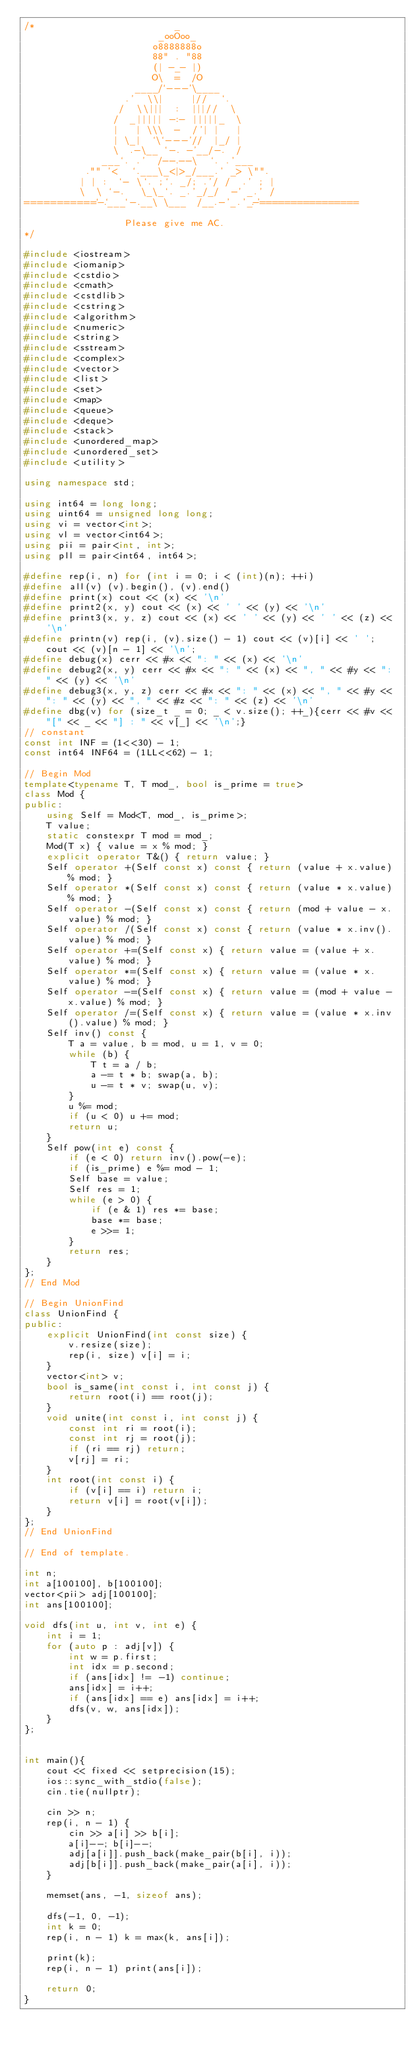Convert code to text. <code><loc_0><loc_0><loc_500><loc_500><_C++_>/*                         _
                        _ooOoo_
                       o8888888o
                       88" . "88
                       (| -_- |)
                       O\  =  /O
                    ____/`---'\____
                  .'  \\|     |//  `.
                 /  \\|||  :  |||//  \
                /  _||||| -:- |||||_  \
                |   | \\\  -  /'| |   |
                | \_|  `\`---'//  |_/ |
                \  .-\__ `-. -'__/-.  /
              ___`. .'  /--.--\  `. .'___
           ."" '<  `.___\_<|>_/___.' _> \"".
          | | :  `- \`. ;`. _/; .'/ /  .' ; |
          \  \ `-.   \_\_`. _.'_/_/  -' _.' /
===========`-.`___`-.__\ \___  /__.-'_.'_.-'================

                  Please give me AC.
*/

#include <iostream>
#include <iomanip>
#include <cstdio>
#include <cmath>
#include <cstdlib>
#include <cstring>
#include <algorithm>
#include <numeric>
#include <string>
#include <sstream>
#include <complex>
#include <vector>
#include <list>
#include <set>
#include <map>
#include <queue>
#include <deque>
#include <stack>
#include <unordered_map>
#include <unordered_set>
#include <utility>

using namespace std;

using int64 = long long;
using uint64 = unsigned long long;
using vi = vector<int>;
using vl = vector<int64>;
using pii = pair<int, int>;
using pll = pair<int64, int64>;

#define rep(i, n) for (int i = 0; i < (int)(n); ++i)
#define all(v) (v).begin(), (v).end()
#define print(x) cout << (x) << '\n'
#define print2(x, y) cout << (x) << ' ' << (y) << '\n'
#define print3(x, y, z) cout << (x) << ' ' << (y) << ' ' << (z) << '\n'
#define printn(v) rep(i, (v).size() - 1) cout << (v)[i] << ' '; cout << (v)[n - 1] << '\n';
#define debug(x) cerr << #x << ": " << (x) << '\n'
#define debug2(x, y) cerr << #x << ": " << (x) << ", " << #y << ": " << (y) << '\n'
#define debug3(x, y, z) cerr << #x << ": " << (x) << ", " << #y << ": " << (y) << ", " << #z << ": " << (z) << '\n'
#define dbg(v) for (size_t _ = 0; _ < v.size(); ++_){cerr << #v << "[" << _ << "] : " << v[_] << '\n';}
// constant
const int INF = (1<<30) - 1;
const int64 INF64 = (1LL<<62) - 1;

// Begin Mod
template<typename T, T mod_, bool is_prime = true>
class Mod {
public:
    using Self = Mod<T, mod_, is_prime>;
    T value;
    static constexpr T mod = mod_;
    Mod(T x) { value = x % mod; }
    explicit operator T&() { return value; }
    Self operator +(Self const x) const { return (value + x.value) % mod; }
    Self operator *(Self const x) const { return (value * x.value) % mod; }
    Self operator -(Self const x) const { return (mod + value - x.value) % mod; }
    Self operator /(Self const x) const { return (value * x.inv().value) % mod; }
    Self operator +=(Self const x) { return value = (value + x.value) % mod; }
    Self operator *=(Self const x) { return value = (value * x.value) % mod; }
    Self operator -=(Self const x) { return value = (mod + value - x.value) % mod; }
    Self operator /=(Self const x) { return value = (value * x.inv().value) % mod; }
    Self inv() const {
        T a = value, b = mod, u = 1, v = 0;
        while (b) {
            T t = a / b;
            a -= t * b; swap(a, b);
            u -= t * v; swap(u, v);
        }
        u %= mod;
        if (u < 0) u += mod;
        return u;
    }
    Self pow(int e) const {
        if (e < 0) return inv().pow(-e);
        if (is_prime) e %= mod - 1;
        Self base = value;
        Self res = 1;
        while (e > 0) {
            if (e & 1) res *= base;
            base *= base;
            e >>= 1;
        }
        return res;
    }
};
// End Mod

// Begin UnionFind
class UnionFind {
public:
    explicit UnionFind(int const size) {
        v.resize(size);
        rep(i, size) v[i] = i;
    }
    vector<int> v;
    bool is_same(int const i, int const j) {
        return root(i) == root(j);
    }
    void unite(int const i, int const j) {
        const int ri = root(i);
        const int rj = root(j);
        if (ri == rj) return;
        v[rj] = ri;
    }
    int root(int const i) {
        if (v[i] == i) return i;
        return v[i] = root(v[i]);
    }
};
// End UnionFind

// End of template.

int n;
int a[100100], b[100100];
vector<pii> adj[100100];
int ans[100100];

void dfs(int u, int v, int e) {
    int i = 1;
    for (auto p : adj[v]) {
        int w = p.first;
        int idx = p.second;
        if (ans[idx] != -1) continue;
        ans[idx] = i++;
        if (ans[idx] == e) ans[idx] = i++;
        dfs(v, w, ans[idx]);
    }
};


int main(){
    cout << fixed << setprecision(15);
    ios::sync_with_stdio(false);
    cin.tie(nullptr);

    cin >> n;
    rep(i, n - 1) {
        cin >> a[i] >> b[i];
        a[i]--; b[i]--;
        adj[a[i]].push_back(make_pair(b[i], i));
        adj[b[i]].push_back(make_pair(a[i], i));
    }

    memset(ans, -1, sizeof ans);

    dfs(-1, 0, -1);
    int k = 0;
    rep(i, n - 1) k = max(k, ans[i]);

    print(k);
    rep(i, n - 1) print(ans[i]);

    return 0;
}

</code> 